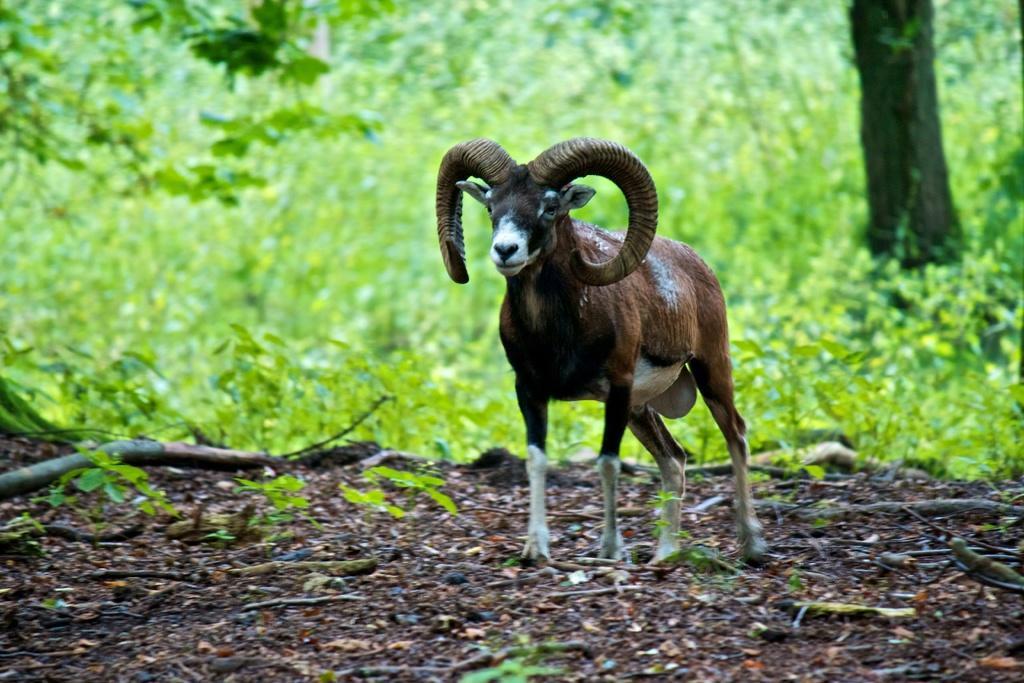How would you summarize this image in a sentence or two? This picture might be taken from forest. In this image, in the middle there is an animal walking on the land. In the background, there are some trees and plants, at the bottom there is a land with some stones. 